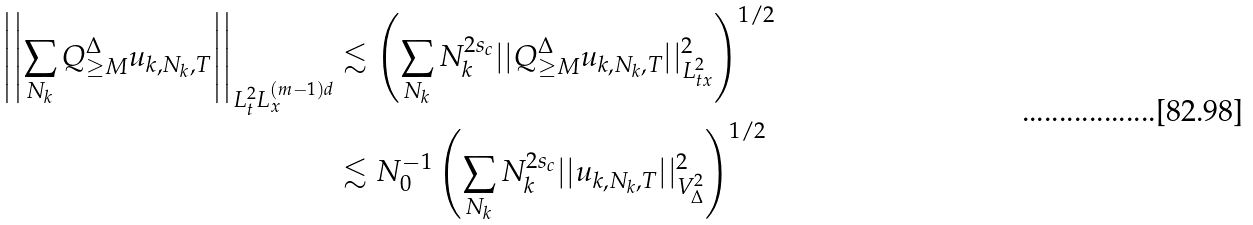<formula> <loc_0><loc_0><loc_500><loc_500>\left | \left | \sum _ { N _ { k } } Q _ { \geq M } ^ { \Delta } u _ { k , N _ { k } , T } \right | \right | _ { L _ { t } ^ { 2 } L _ { x } ^ { ( m - 1 ) d } } & \lesssim \left ( \sum _ { N _ { k } } N _ { k } ^ { 2 s _ { c } } | | Q _ { \geq M } ^ { \Delta } u _ { k , N _ { k } , T } | | _ { L _ { t x } ^ { 2 } } ^ { 2 } \right ) ^ { 1 / 2 } \\ & \lesssim N _ { 0 } ^ { - 1 } \left ( \sum _ { N _ { k } } N _ { k } ^ { 2 s _ { c } } | | u _ { k , N _ { k } , T } | | _ { V ^ { 2 } _ { \Delta } } ^ { 2 } \right ) ^ { 1 / 2 }</formula> 